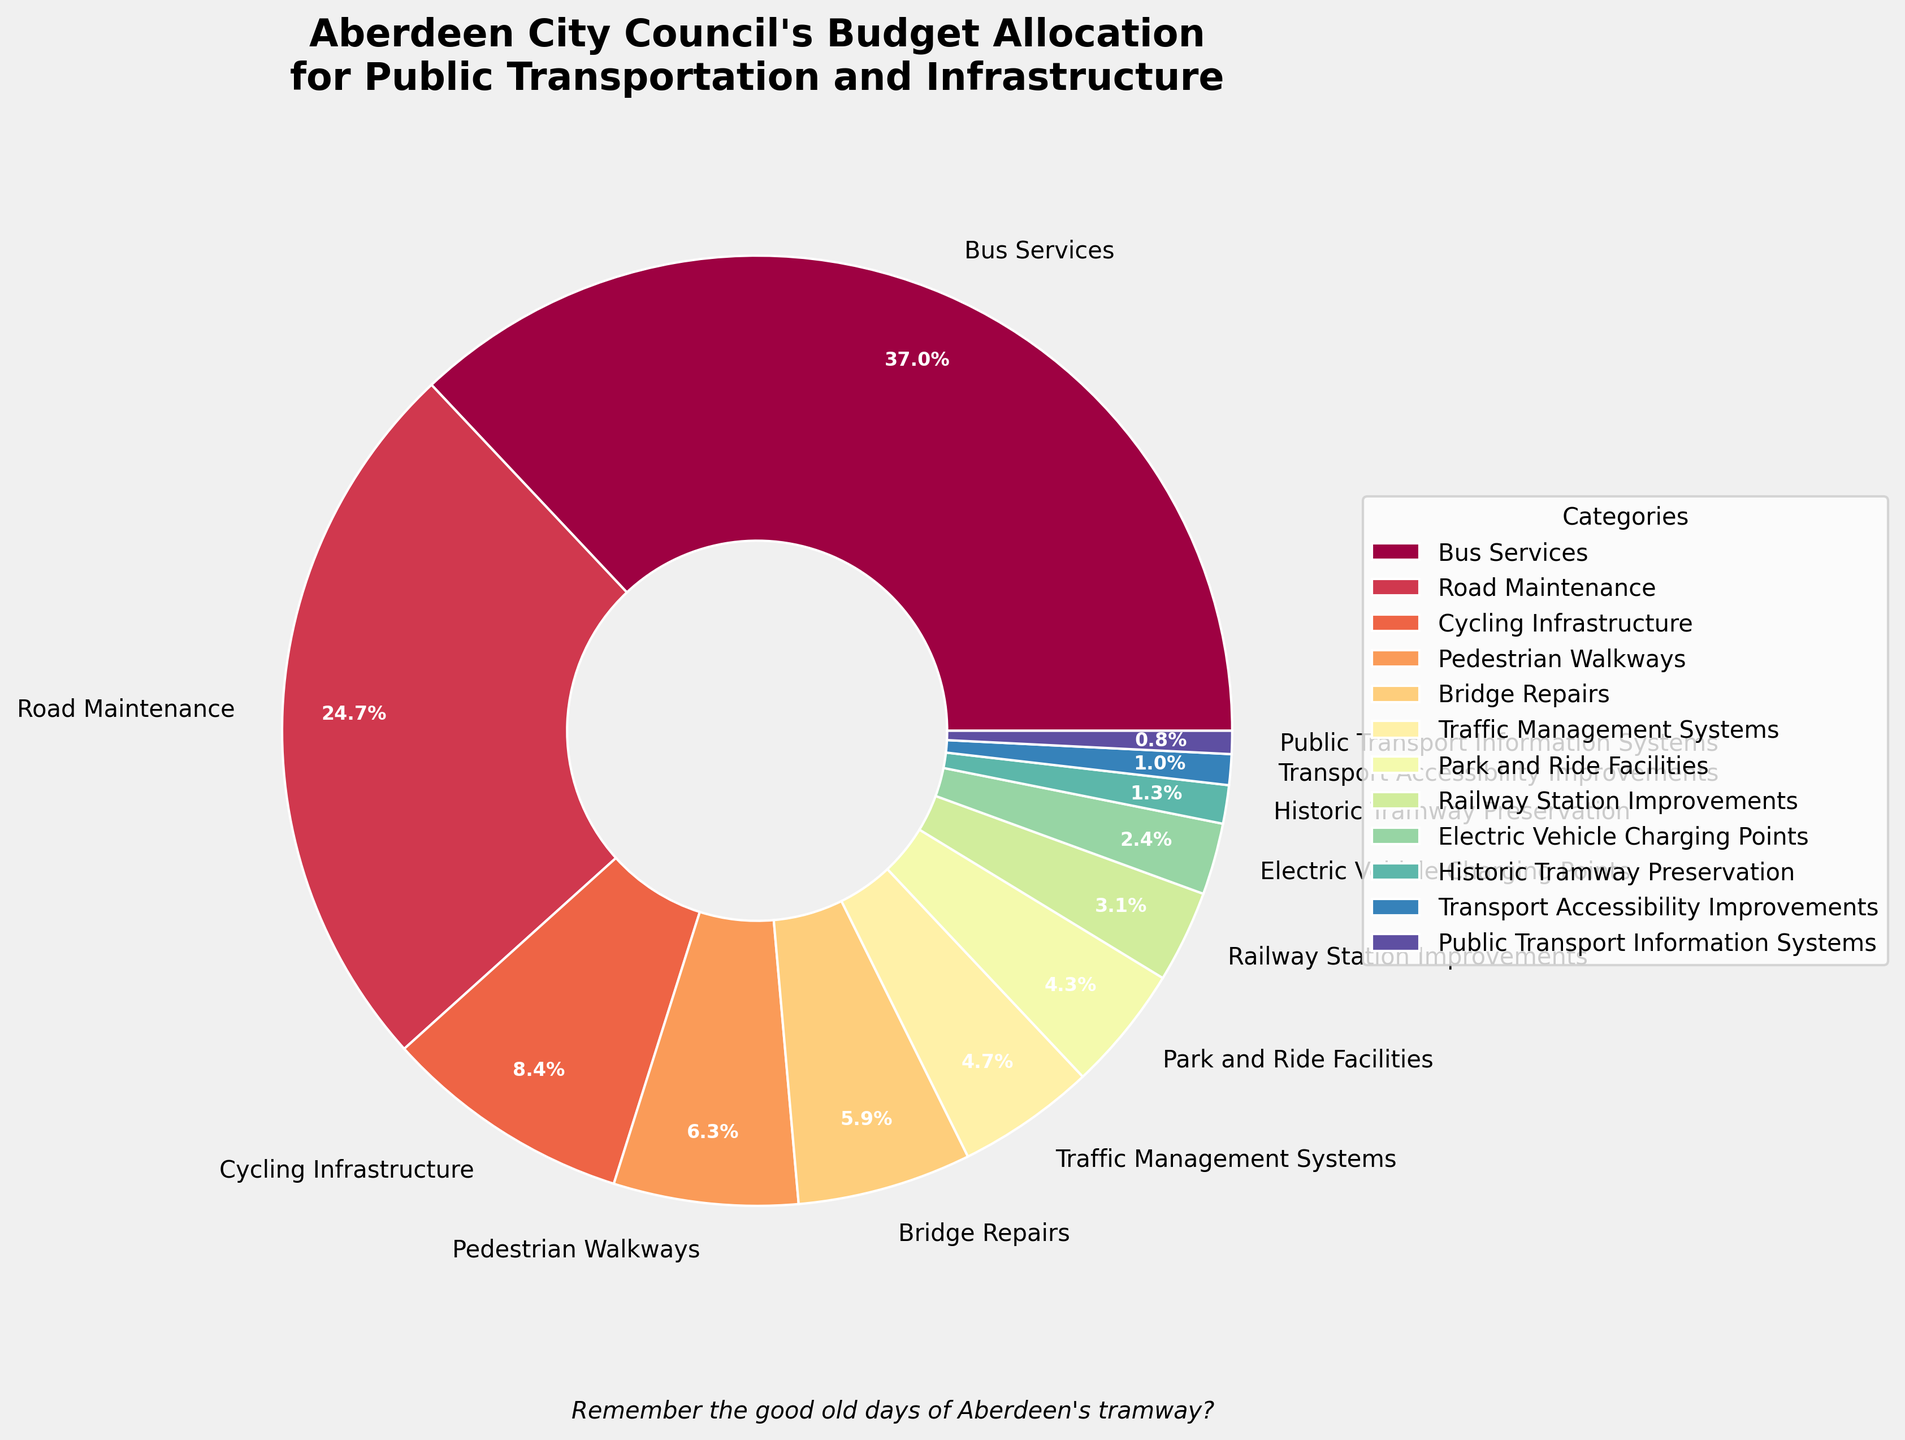Which category has the highest budget allocation? From the chart, the "Bus Services" category takes up the largest portion of the pie chart.
Answer: Bus Services How much more budget is allocated to Road Maintenance compared to Cycling Infrastructure? According to the chart, Road Maintenance is allocated £28.3 million and Cycling Infrastructure is allocated £9.7 million. The difference is calculated as: £28.3 million - £9.7 million = £18.6 million.
Answer: £18.6 million Which category has the smallest budget allocation, and what percentage of the total budget does it represent? Public Transport Information Systems has the smallest segment on the pie chart. It is allocated £0.9 million out of the total budget sum. The percentage is calculated as: (£0.9 million / total budget) * 100 = (£0.9 million / 114.8 million) * 100 ≈ 0.8%.
Answer: Public Transport Information Systems, 0.8% Are Bridge Repairs allocated more or less budget than Park and Ride Facilities? From the pie chart, we see that Bridge Repairs are allotted £6.8 million whereas Park and Ride Facilities are allotted £4.9 million. Therefore, Bridge Repairs have a higher budget.
Answer: More What is the total budget allocated to categories related to cycling and pedestrian infrastructure (Cycling Infrastructure, Pedestrian Walkways)? According to the chart, Cycling Infrastructure is allocated £9.7 million and Pedestrian Walkways are allocated £7.2 million. Their total is: £9.7 million + £7.2 million = £16.9 million.
Answer: £16.9 million What category is allocated 2.8% of the total budget? Referring to the chart, Electric Vehicle Charging Points takes up 2.8% of the budget.
Answer: Electric Vehicle Charging Points What is the combined budget for Historic Tramway Preservation and Transport Accessibility Improvements? The pie chart indicates that Historic Tramway Preservation is allocated £1.5 million and Transport Accessibility Improvements are allocated £1.2 million. Their sum is: £1.5 million + £1.2 million = £2.7 million.
Answer: £2.7 million Is the budget for Electric Vehicle Charging Points more or less than the combined budget for Public Transport Information Systems and Transport Accessibility Improvements? Electric Vehicle Charging Points are given £2.8 million. Public Transport Information Systems are allocated £0.9 million and Transport Accessibility Improvements are allocated £1.2 million. Their combined budget is: £0.9 million + £1.2 million = £2.1 million. Thus, £2.8 million is greater than £2.1 million.
Answer: More Which categories have an allocation of less than £5 million? From the chart, the categories with allocations less than £5 million are Park and Ride Facilities (£4.9 million), Railway Station Improvements (£3.6 million), Electric Vehicle Charging Points (£2.8 million), Historic Tramway Preservation (£1.5 million), Transport Accessibility Improvements (£1.2 million), and Public Transport Information Systems (£0.9 million).
Answer: Park and Ride Facilities, Railway Station Improvements, Electric Vehicle Charging Points, Historic Tramway Preservation, Transport Accessibility Improvements, Public Transport Information Systems 